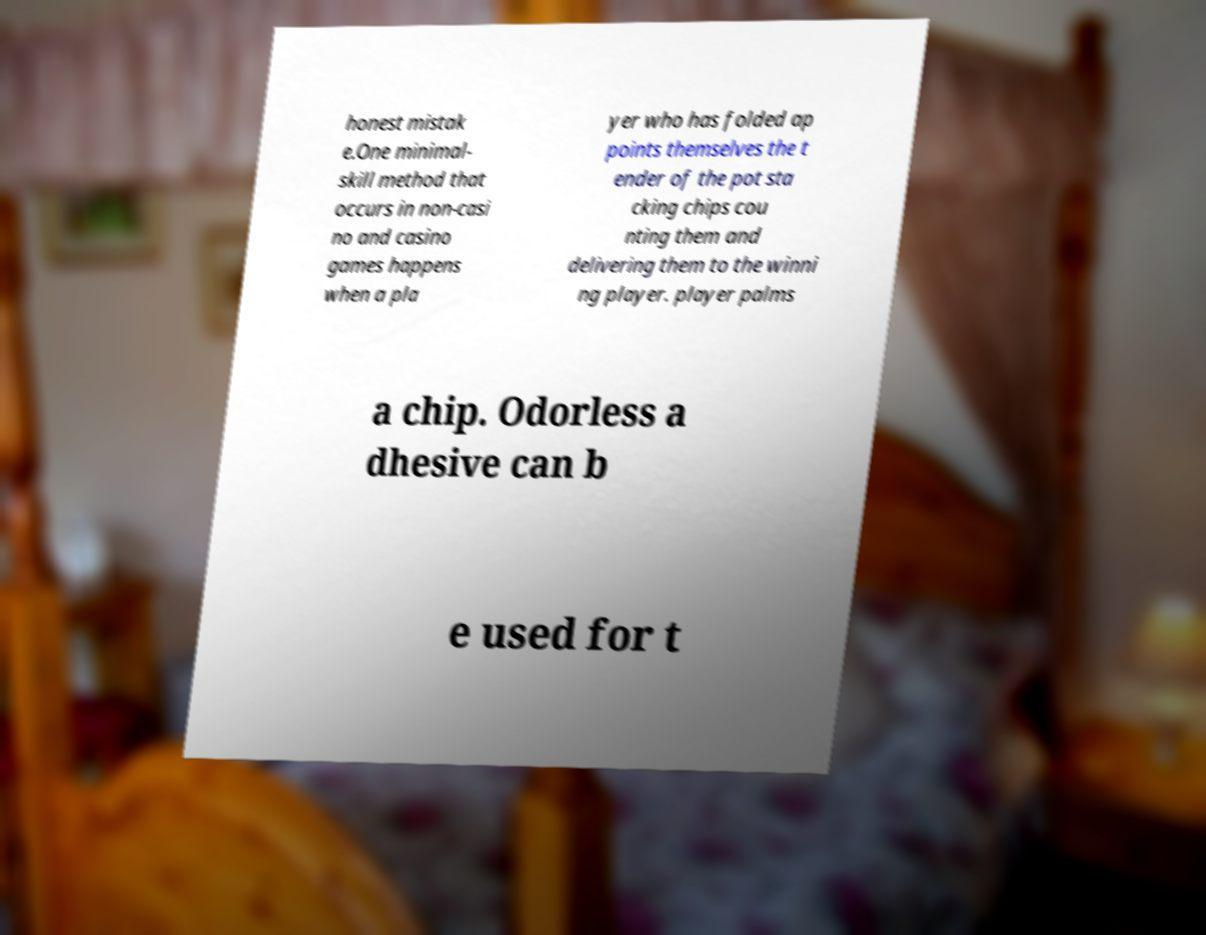What messages or text are displayed in this image? I need them in a readable, typed format. honest mistak e.One minimal- skill method that occurs in non-casi no and casino games happens when a pla yer who has folded ap points themselves the t ender of the pot sta cking chips cou nting them and delivering them to the winni ng player. player palms a chip. Odorless a dhesive can b e used for t 